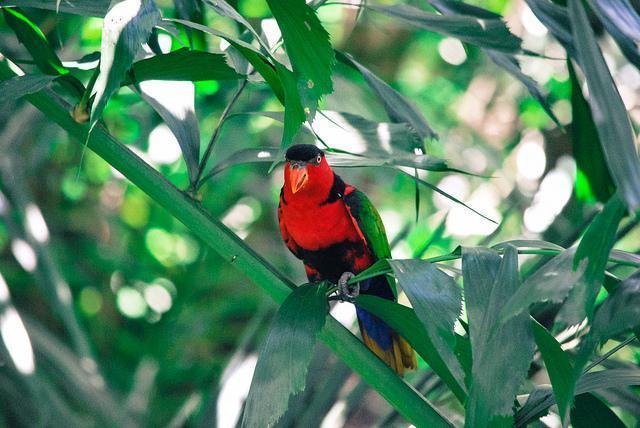How many birds are in the picture?
Give a very brief answer. 1. How many eyes are there?
Give a very brief answer. 2. 